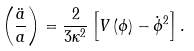Convert formula to latex. <formula><loc_0><loc_0><loc_500><loc_500>\left ( { \frac { \ddot { a } } { a } } \right ) = { \frac { 2 } { 3 \kappa ^ { 2 } } } \left [ V \left ( \phi \right ) - \dot { \phi } ^ { 2 } \right ] .</formula> 